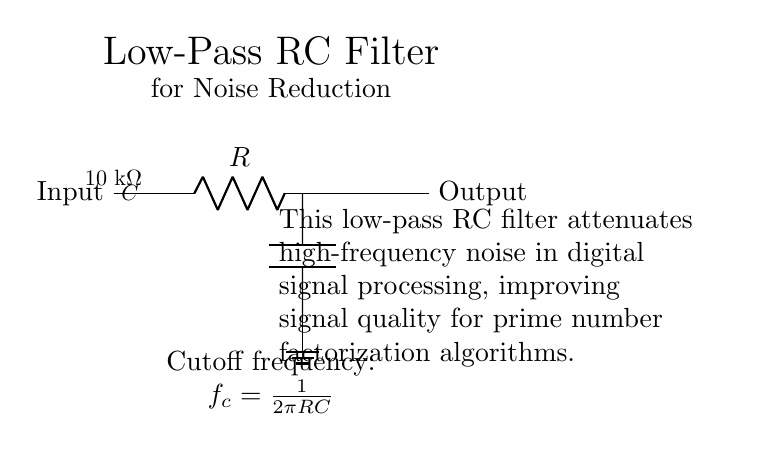What are the components of this circuit? The circuit contains a resistor and a capacitor, which are the key components of a low-pass filter.
Answer: Resistor and capacitor What is the value of the resistor used in the circuit? The resistor is labeled as having a value of ten kilo-ohms, indicated in the diagram.
Answer: Ten kilo-ohms What is the purpose of the low-pass RC filter in this circuit? The filter is designed to attenuate high-frequency noise, enhancing the quality of digital signals for processing tasks.
Answer: Noise reduction How is the cutoff frequency of the filter determined? The cutoff frequency is calculated using the formula f_c = 1 / (2πRC), which involves both resistance and capacitance values.
Answer: One over two pi RC What happens to high-frequency signals in this design? High-frequency signals experience attenuation due to the filter design, allowing mainly low-frequency signals to pass.
Answer: They are attenuated What main characteristic distinguishes this circuit as a low-pass filter? The distinguishing characteristic is that it allows low-frequency signals to pass while blocking or reducing high-frequency signals.
Answer: It allows low-frequency signals What is the output configuration of the circuit? The output is taken after the capacitor, providing a cleaner signal with reduced noise.
Answer: After the capacitor 